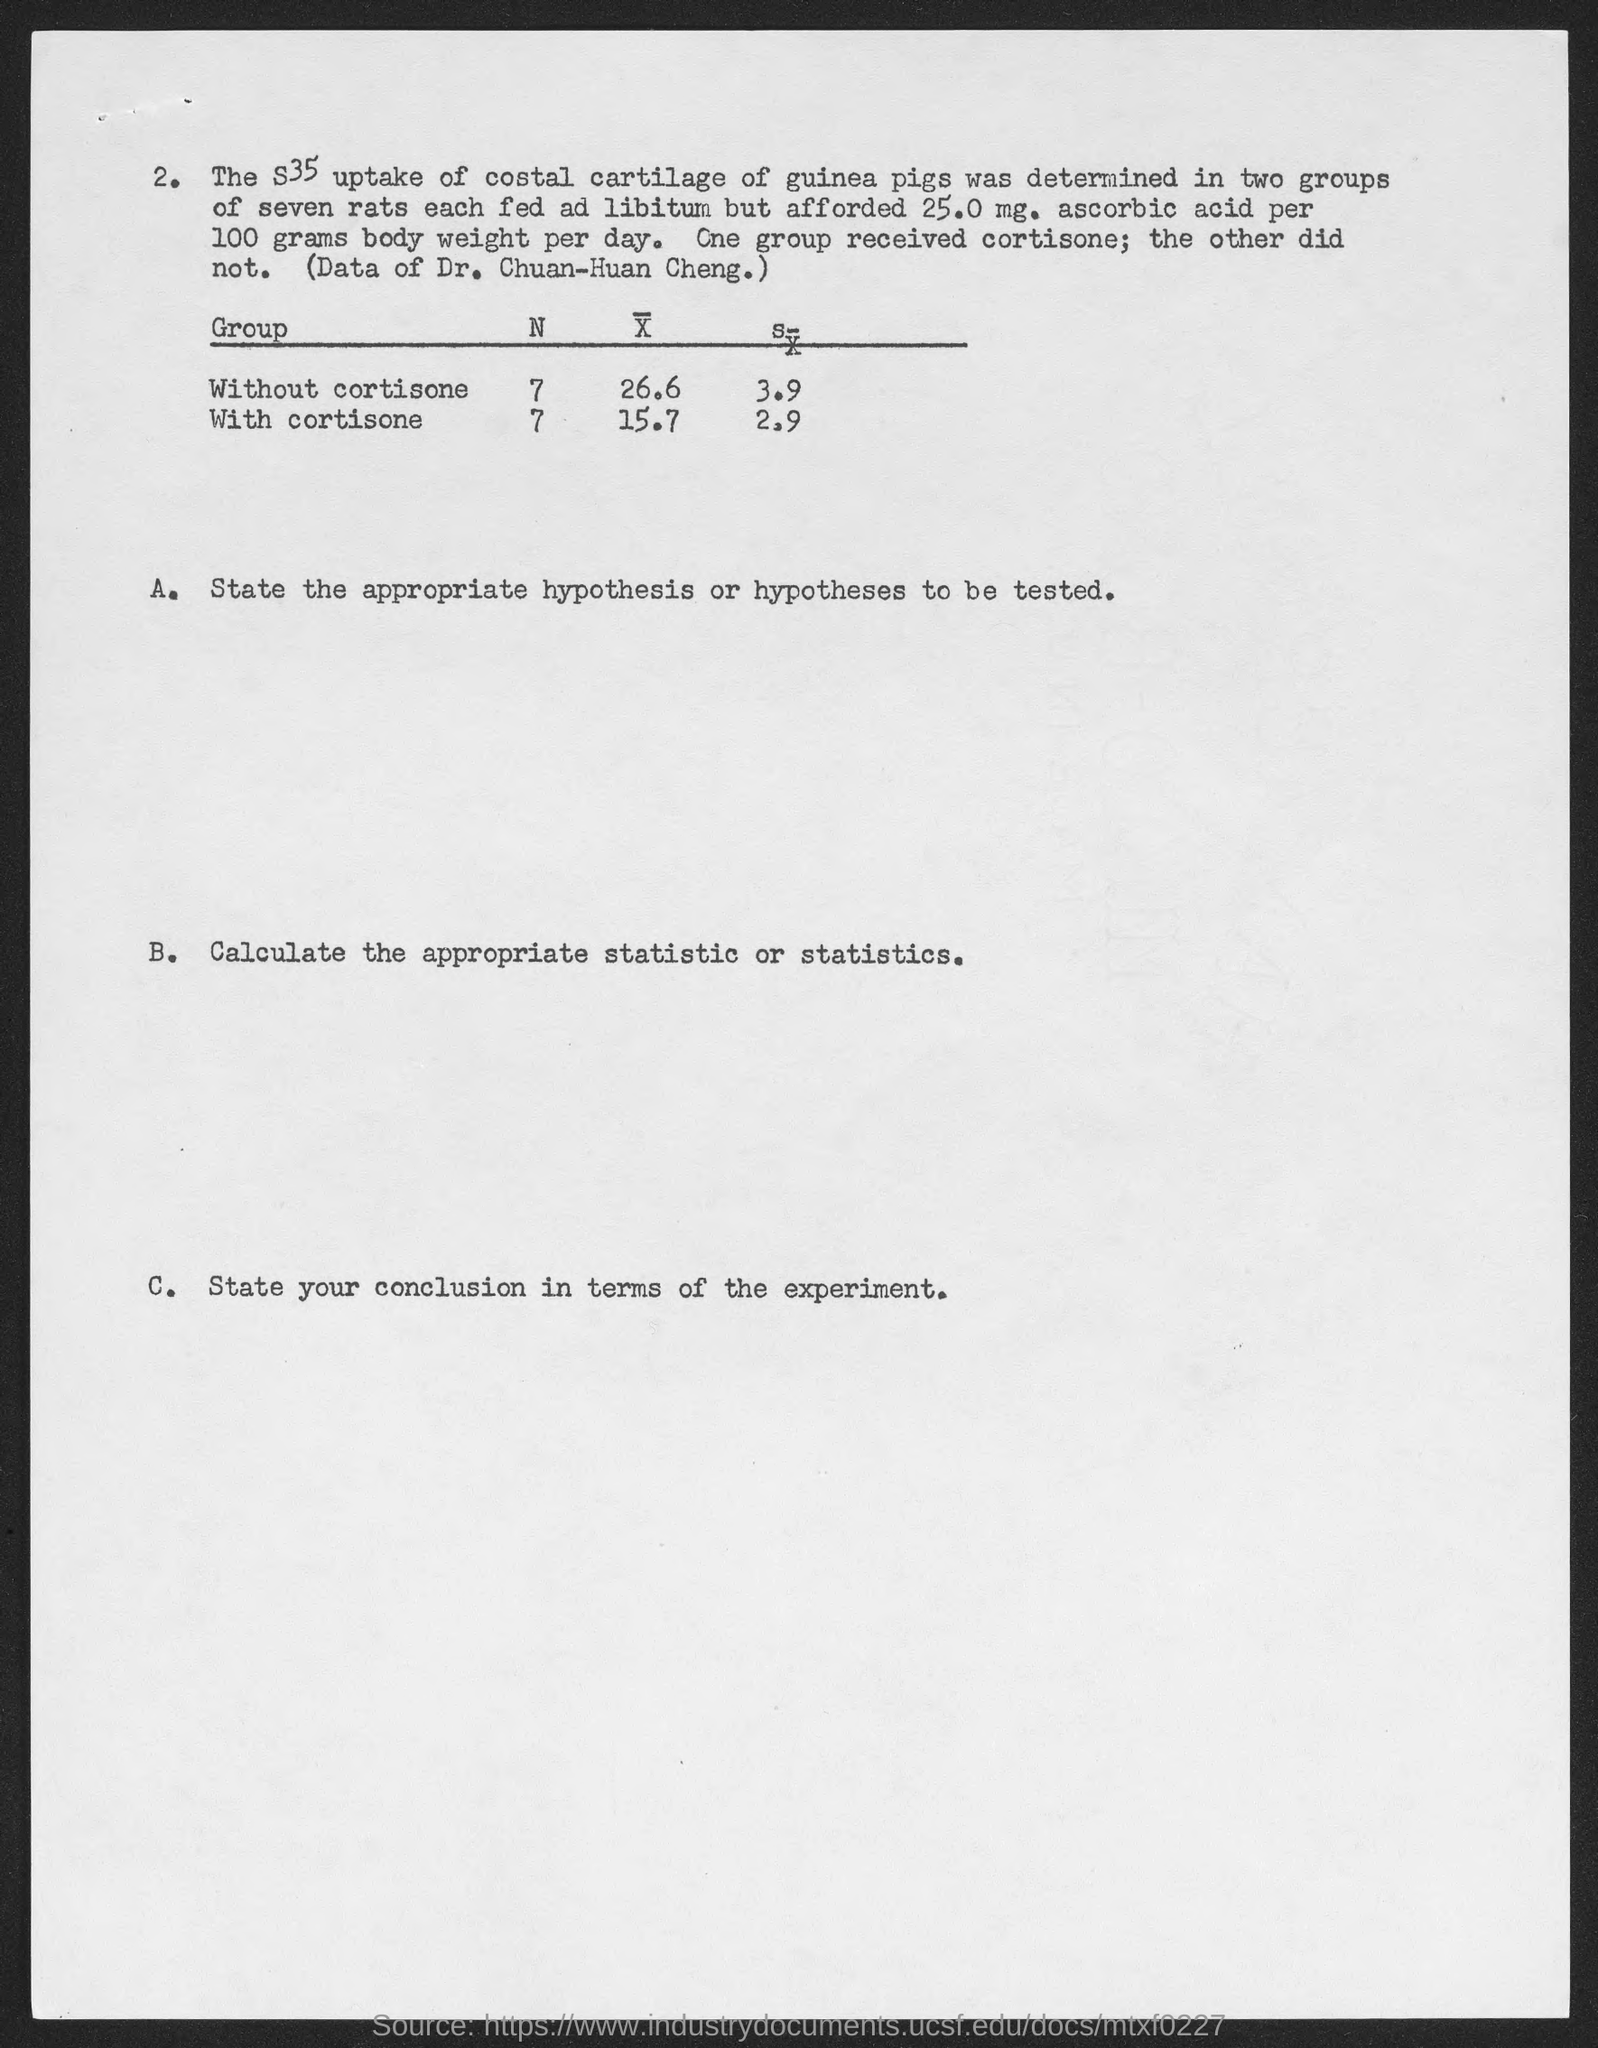Point out several critical features in this image. Please mention the heading of the first column of the table. The rats were given a daily dose of 25.0 mg of ascorbic acid per 100 gms of body weight. The value of 'N' for the 'Without cortisone' group is 7. The first group listed in the table is the one without cortisone. The table lists various "Groups" along with the number of patients assigned to each group in the study. One of the groups listed is "Group 2," which is given the second highest number of patients among all the groups. Additionally, cortisone is mentioned as a potential treatment for the patients in the study. 